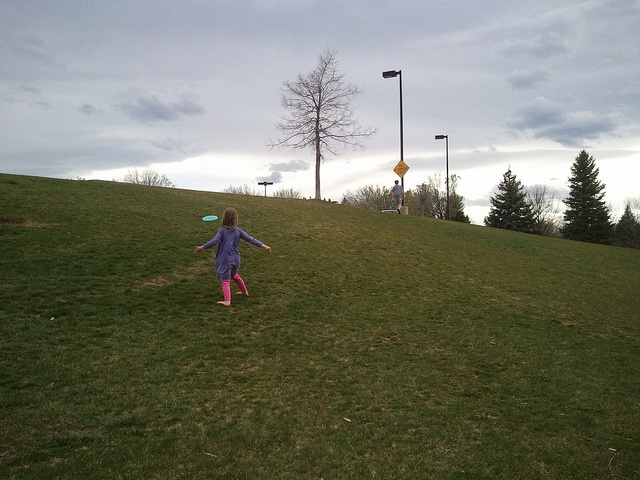Describe the objects in this image and their specific colors. I can see people in darkgray, purple, black, navy, and maroon tones, people in darkgray, gray, and black tones, and frisbee in darkgray, turquoise, darkgreen, lightblue, and teal tones in this image. 